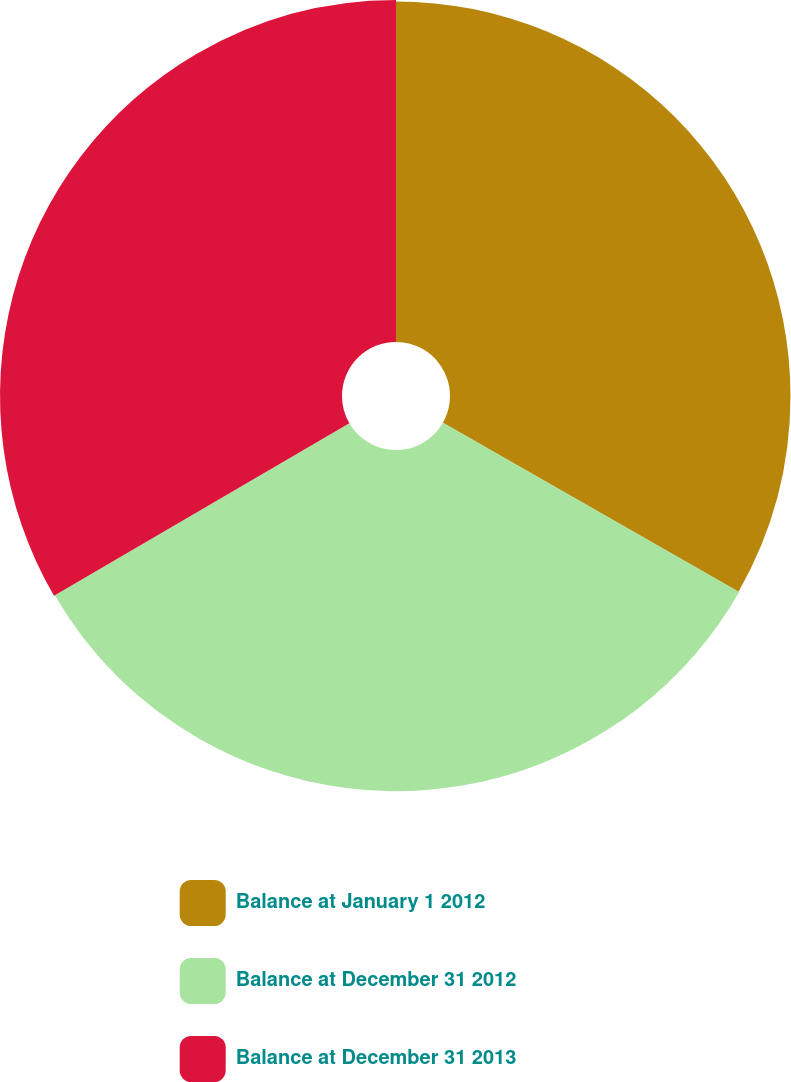Convert chart. <chart><loc_0><loc_0><loc_500><loc_500><pie_chart><fcel>Balance at January 1 2012<fcel>Balance at December 31 2012<fcel>Balance at December 31 2013<nl><fcel>33.26%<fcel>33.33%<fcel>33.41%<nl></chart> 